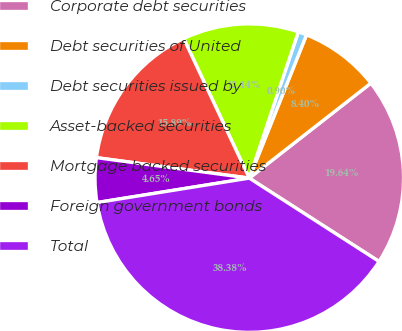Convert chart. <chart><loc_0><loc_0><loc_500><loc_500><pie_chart><fcel>Corporate debt securities<fcel>Debt securities of United<fcel>Debt securities issued by<fcel>Asset-backed securities<fcel>Mortgage backed securities<fcel>Foreign government bonds<fcel>Total<nl><fcel>19.64%<fcel>8.4%<fcel>0.9%<fcel>12.14%<fcel>15.89%<fcel>4.65%<fcel>38.38%<nl></chart> 